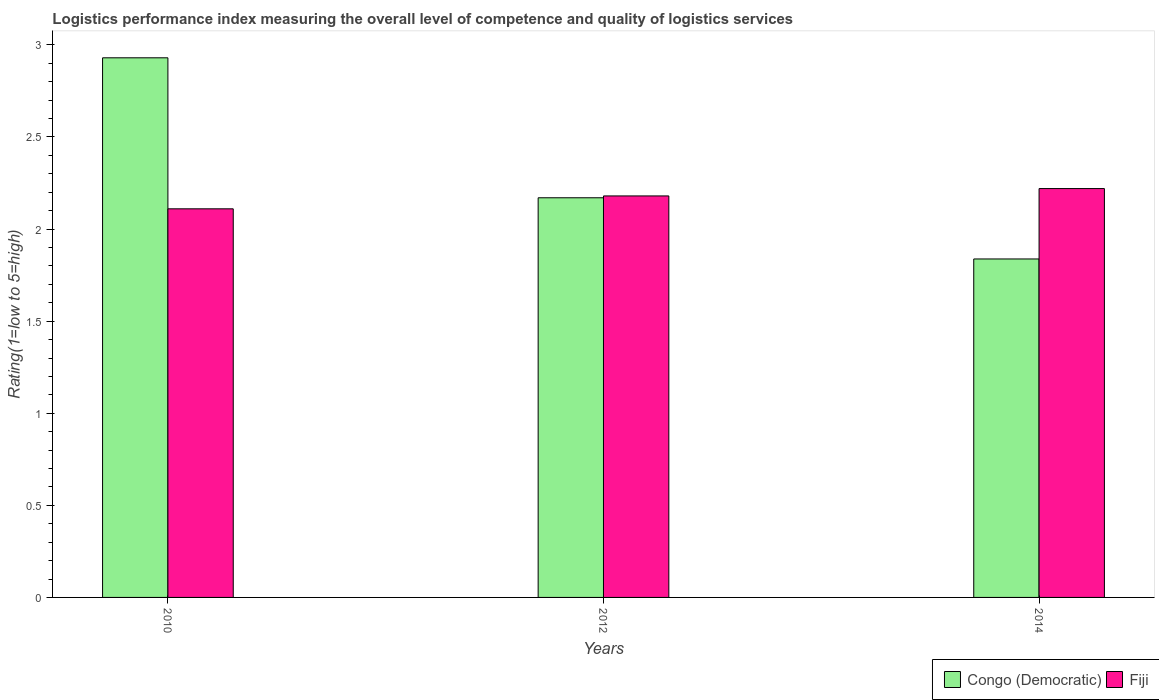How many different coloured bars are there?
Your answer should be compact. 2. How many groups of bars are there?
Your answer should be compact. 3. Are the number of bars per tick equal to the number of legend labels?
Keep it short and to the point. Yes. How many bars are there on the 3rd tick from the right?
Your response must be concise. 2. What is the label of the 2nd group of bars from the left?
Ensure brevity in your answer.  2012. What is the Logistic performance index in Congo (Democratic) in 2012?
Make the answer very short. 2.17. Across all years, what is the maximum Logistic performance index in Congo (Democratic)?
Give a very brief answer. 2.93. Across all years, what is the minimum Logistic performance index in Fiji?
Your answer should be compact. 2.11. In which year was the Logistic performance index in Fiji maximum?
Give a very brief answer. 2014. In which year was the Logistic performance index in Fiji minimum?
Offer a very short reply. 2010. What is the total Logistic performance index in Fiji in the graph?
Your answer should be very brief. 6.51. What is the difference between the Logistic performance index in Fiji in 2010 and that in 2012?
Your answer should be compact. -0.07. What is the difference between the Logistic performance index in Fiji in 2014 and the Logistic performance index in Congo (Democratic) in 2012?
Ensure brevity in your answer.  0.05. What is the average Logistic performance index in Congo (Democratic) per year?
Your answer should be compact. 2.31. In the year 2012, what is the difference between the Logistic performance index in Congo (Democratic) and Logistic performance index in Fiji?
Keep it short and to the point. -0.01. In how many years, is the Logistic performance index in Fiji greater than 2.2?
Your answer should be compact. 1. What is the ratio of the Logistic performance index in Fiji in 2010 to that in 2012?
Give a very brief answer. 0.97. What is the difference between the highest and the second highest Logistic performance index in Fiji?
Offer a terse response. 0.04. What is the difference between the highest and the lowest Logistic performance index in Congo (Democratic)?
Your response must be concise. 1.09. What does the 2nd bar from the left in 2010 represents?
Your response must be concise. Fiji. What does the 2nd bar from the right in 2010 represents?
Ensure brevity in your answer.  Congo (Democratic). How many bars are there?
Provide a succinct answer. 6. Does the graph contain any zero values?
Make the answer very short. No. Does the graph contain grids?
Your answer should be very brief. No. Where does the legend appear in the graph?
Your answer should be compact. Bottom right. How many legend labels are there?
Ensure brevity in your answer.  2. How are the legend labels stacked?
Provide a short and direct response. Horizontal. What is the title of the graph?
Provide a succinct answer. Logistics performance index measuring the overall level of competence and quality of logistics services. What is the label or title of the X-axis?
Give a very brief answer. Years. What is the label or title of the Y-axis?
Your answer should be very brief. Rating(1=low to 5=high). What is the Rating(1=low to 5=high) in Congo (Democratic) in 2010?
Your response must be concise. 2.93. What is the Rating(1=low to 5=high) of Fiji in 2010?
Your answer should be very brief. 2.11. What is the Rating(1=low to 5=high) in Congo (Democratic) in 2012?
Your answer should be compact. 2.17. What is the Rating(1=low to 5=high) of Fiji in 2012?
Offer a very short reply. 2.18. What is the Rating(1=low to 5=high) in Congo (Democratic) in 2014?
Your response must be concise. 1.84. What is the Rating(1=low to 5=high) of Fiji in 2014?
Offer a terse response. 2.22. Across all years, what is the maximum Rating(1=low to 5=high) in Congo (Democratic)?
Keep it short and to the point. 2.93. Across all years, what is the maximum Rating(1=low to 5=high) in Fiji?
Keep it short and to the point. 2.22. Across all years, what is the minimum Rating(1=low to 5=high) of Congo (Democratic)?
Your answer should be compact. 1.84. Across all years, what is the minimum Rating(1=low to 5=high) of Fiji?
Offer a terse response. 2.11. What is the total Rating(1=low to 5=high) of Congo (Democratic) in the graph?
Provide a succinct answer. 6.94. What is the total Rating(1=low to 5=high) of Fiji in the graph?
Your response must be concise. 6.51. What is the difference between the Rating(1=low to 5=high) in Congo (Democratic) in 2010 and that in 2012?
Offer a very short reply. 0.76. What is the difference between the Rating(1=low to 5=high) of Fiji in 2010 and that in 2012?
Your answer should be very brief. -0.07. What is the difference between the Rating(1=low to 5=high) of Congo (Democratic) in 2010 and that in 2014?
Give a very brief answer. 1.09. What is the difference between the Rating(1=low to 5=high) in Fiji in 2010 and that in 2014?
Provide a short and direct response. -0.11. What is the difference between the Rating(1=low to 5=high) in Congo (Democratic) in 2012 and that in 2014?
Provide a succinct answer. 0.33. What is the difference between the Rating(1=low to 5=high) of Fiji in 2012 and that in 2014?
Provide a short and direct response. -0.04. What is the difference between the Rating(1=low to 5=high) of Congo (Democratic) in 2010 and the Rating(1=low to 5=high) of Fiji in 2012?
Your answer should be compact. 0.75. What is the difference between the Rating(1=low to 5=high) of Congo (Democratic) in 2010 and the Rating(1=low to 5=high) of Fiji in 2014?
Offer a very short reply. 0.71. What is the average Rating(1=low to 5=high) in Congo (Democratic) per year?
Your response must be concise. 2.31. What is the average Rating(1=low to 5=high) in Fiji per year?
Provide a short and direct response. 2.17. In the year 2010, what is the difference between the Rating(1=low to 5=high) in Congo (Democratic) and Rating(1=low to 5=high) in Fiji?
Ensure brevity in your answer.  0.82. In the year 2012, what is the difference between the Rating(1=low to 5=high) of Congo (Democratic) and Rating(1=low to 5=high) of Fiji?
Make the answer very short. -0.01. In the year 2014, what is the difference between the Rating(1=low to 5=high) of Congo (Democratic) and Rating(1=low to 5=high) of Fiji?
Provide a short and direct response. -0.38. What is the ratio of the Rating(1=low to 5=high) in Congo (Democratic) in 2010 to that in 2012?
Ensure brevity in your answer.  1.35. What is the ratio of the Rating(1=low to 5=high) in Fiji in 2010 to that in 2012?
Keep it short and to the point. 0.97. What is the ratio of the Rating(1=low to 5=high) of Congo (Democratic) in 2010 to that in 2014?
Your answer should be compact. 1.59. What is the ratio of the Rating(1=low to 5=high) in Fiji in 2010 to that in 2014?
Your response must be concise. 0.95. What is the ratio of the Rating(1=low to 5=high) in Congo (Democratic) in 2012 to that in 2014?
Your answer should be compact. 1.18. What is the difference between the highest and the second highest Rating(1=low to 5=high) of Congo (Democratic)?
Ensure brevity in your answer.  0.76. What is the difference between the highest and the lowest Rating(1=low to 5=high) in Congo (Democratic)?
Your answer should be very brief. 1.09. What is the difference between the highest and the lowest Rating(1=low to 5=high) in Fiji?
Give a very brief answer. 0.11. 